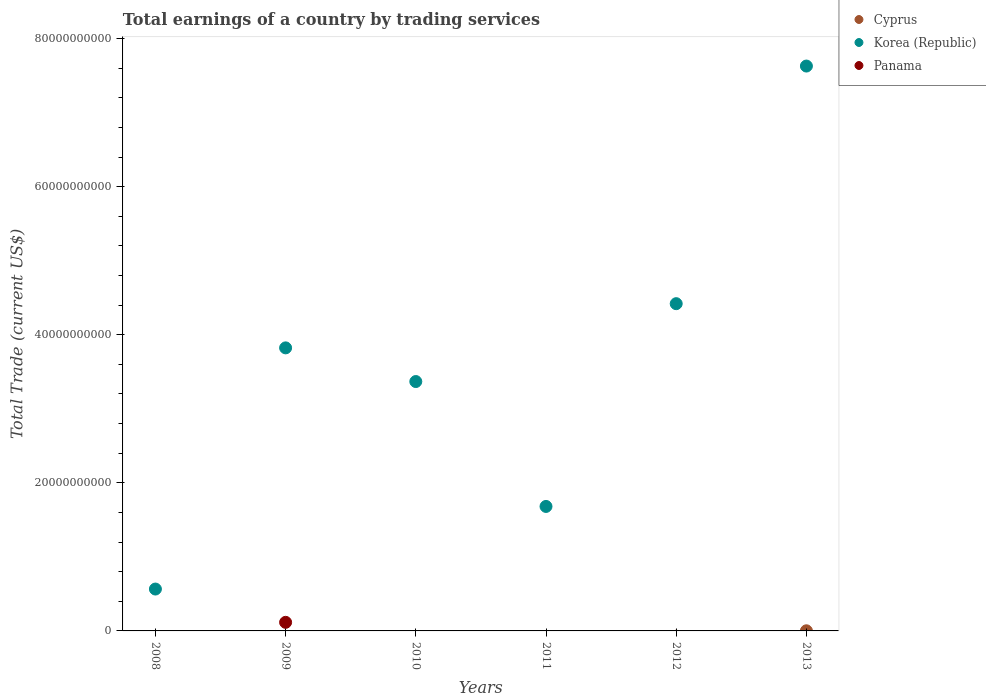What is the total earnings in Panama in 2011?
Provide a succinct answer. 0. Across all years, what is the maximum total earnings in Korea (Republic)?
Your response must be concise. 7.63e+1. Across all years, what is the minimum total earnings in Korea (Republic)?
Give a very brief answer. 5.65e+09. In which year was the total earnings in Cyprus maximum?
Your answer should be compact. 2013. What is the total total earnings in Panama in the graph?
Ensure brevity in your answer.  1.16e+09. What is the difference between the total earnings in Korea (Republic) in 2011 and that in 2013?
Your answer should be compact. -5.95e+1. What is the difference between the total earnings in Korea (Republic) in 2012 and the total earnings in Panama in 2008?
Give a very brief answer. 4.42e+1. What is the average total earnings in Korea (Republic) per year?
Keep it short and to the point. 3.58e+1. In the year 2009, what is the difference between the total earnings in Panama and total earnings in Korea (Republic)?
Ensure brevity in your answer.  -3.71e+1. In how many years, is the total earnings in Cyprus greater than 52000000000 US$?
Offer a terse response. 0. What is the ratio of the total earnings in Korea (Republic) in 2009 to that in 2013?
Your response must be concise. 0.5. Is the total earnings in Korea (Republic) in 2008 less than that in 2009?
Offer a terse response. Yes. What is the difference between the highest and the second highest total earnings in Korea (Republic)?
Keep it short and to the point. 3.21e+1. What is the difference between the highest and the lowest total earnings in Cyprus?
Give a very brief answer. 1.86e+07. In how many years, is the total earnings in Cyprus greater than the average total earnings in Cyprus taken over all years?
Your answer should be very brief. 1. Does the total earnings in Cyprus monotonically increase over the years?
Provide a succinct answer. No. How many dotlines are there?
Give a very brief answer. 3. Does the graph contain grids?
Your answer should be compact. No. Where does the legend appear in the graph?
Your answer should be compact. Top right. How many legend labels are there?
Your response must be concise. 3. How are the legend labels stacked?
Ensure brevity in your answer.  Vertical. What is the title of the graph?
Your response must be concise. Total earnings of a country by trading services. What is the label or title of the Y-axis?
Offer a terse response. Total Trade (current US$). What is the Total Trade (current US$) of Cyprus in 2008?
Your response must be concise. 0. What is the Total Trade (current US$) in Korea (Republic) in 2008?
Your response must be concise. 5.65e+09. What is the Total Trade (current US$) of Panama in 2008?
Offer a very short reply. 0. What is the Total Trade (current US$) of Cyprus in 2009?
Offer a terse response. 0. What is the Total Trade (current US$) in Korea (Republic) in 2009?
Give a very brief answer. 3.82e+1. What is the Total Trade (current US$) in Panama in 2009?
Give a very brief answer. 1.16e+09. What is the Total Trade (current US$) in Cyprus in 2010?
Offer a terse response. 0. What is the Total Trade (current US$) of Korea (Republic) in 2010?
Keep it short and to the point. 3.37e+1. What is the Total Trade (current US$) in Panama in 2010?
Offer a terse response. 0. What is the Total Trade (current US$) in Korea (Republic) in 2011?
Provide a succinct answer. 1.68e+1. What is the Total Trade (current US$) in Korea (Republic) in 2012?
Keep it short and to the point. 4.42e+1. What is the Total Trade (current US$) in Panama in 2012?
Keep it short and to the point. 0. What is the Total Trade (current US$) of Cyprus in 2013?
Offer a terse response. 1.86e+07. What is the Total Trade (current US$) in Korea (Republic) in 2013?
Your answer should be very brief. 7.63e+1. What is the Total Trade (current US$) in Panama in 2013?
Provide a short and direct response. 0. Across all years, what is the maximum Total Trade (current US$) of Cyprus?
Offer a very short reply. 1.86e+07. Across all years, what is the maximum Total Trade (current US$) in Korea (Republic)?
Keep it short and to the point. 7.63e+1. Across all years, what is the maximum Total Trade (current US$) of Panama?
Ensure brevity in your answer.  1.16e+09. Across all years, what is the minimum Total Trade (current US$) in Korea (Republic)?
Keep it short and to the point. 5.65e+09. Across all years, what is the minimum Total Trade (current US$) of Panama?
Ensure brevity in your answer.  0. What is the total Total Trade (current US$) in Cyprus in the graph?
Provide a short and direct response. 1.86e+07. What is the total Total Trade (current US$) in Korea (Republic) in the graph?
Your response must be concise. 2.15e+11. What is the total Total Trade (current US$) of Panama in the graph?
Your answer should be compact. 1.16e+09. What is the difference between the Total Trade (current US$) of Korea (Republic) in 2008 and that in 2009?
Your answer should be compact. -3.26e+1. What is the difference between the Total Trade (current US$) in Korea (Republic) in 2008 and that in 2010?
Ensure brevity in your answer.  -2.80e+1. What is the difference between the Total Trade (current US$) of Korea (Republic) in 2008 and that in 2011?
Make the answer very short. -1.12e+1. What is the difference between the Total Trade (current US$) in Korea (Republic) in 2008 and that in 2012?
Your answer should be very brief. -3.85e+1. What is the difference between the Total Trade (current US$) of Korea (Republic) in 2008 and that in 2013?
Keep it short and to the point. -7.06e+1. What is the difference between the Total Trade (current US$) in Korea (Republic) in 2009 and that in 2010?
Provide a succinct answer. 4.55e+09. What is the difference between the Total Trade (current US$) in Korea (Republic) in 2009 and that in 2011?
Provide a succinct answer. 2.14e+1. What is the difference between the Total Trade (current US$) of Korea (Republic) in 2009 and that in 2012?
Make the answer very short. -5.97e+09. What is the difference between the Total Trade (current US$) of Korea (Republic) in 2009 and that in 2013?
Your answer should be compact. -3.81e+1. What is the difference between the Total Trade (current US$) in Korea (Republic) in 2010 and that in 2011?
Your answer should be compact. 1.69e+1. What is the difference between the Total Trade (current US$) of Korea (Republic) in 2010 and that in 2012?
Give a very brief answer. -1.05e+1. What is the difference between the Total Trade (current US$) of Korea (Republic) in 2010 and that in 2013?
Make the answer very short. -4.26e+1. What is the difference between the Total Trade (current US$) in Korea (Republic) in 2011 and that in 2012?
Ensure brevity in your answer.  -2.74e+1. What is the difference between the Total Trade (current US$) of Korea (Republic) in 2011 and that in 2013?
Provide a short and direct response. -5.95e+1. What is the difference between the Total Trade (current US$) in Korea (Republic) in 2012 and that in 2013?
Your response must be concise. -3.21e+1. What is the difference between the Total Trade (current US$) of Korea (Republic) in 2008 and the Total Trade (current US$) of Panama in 2009?
Your answer should be compact. 4.50e+09. What is the average Total Trade (current US$) in Cyprus per year?
Offer a very short reply. 3.11e+06. What is the average Total Trade (current US$) in Korea (Republic) per year?
Offer a very short reply. 3.58e+1. What is the average Total Trade (current US$) of Panama per year?
Your answer should be compact. 1.93e+08. In the year 2009, what is the difference between the Total Trade (current US$) of Korea (Republic) and Total Trade (current US$) of Panama?
Provide a succinct answer. 3.71e+1. In the year 2013, what is the difference between the Total Trade (current US$) in Cyprus and Total Trade (current US$) in Korea (Republic)?
Ensure brevity in your answer.  -7.63e+1. What is the ratio of the Total Trade (current US$) in Korea (Republic) in 2008 to that in 2009?
Make the answer very short. 0.15. What is the ratio of the Total Trade (current US$) of Korea (Republic) in 2008 to that in 2010?
Your answer should be very brief. 0.17. What is the ratio of the Total Trade (current US$) of Korea (Republic) in 2008 to that in 2011?
Provide a short and direct response. 0.34. What is the ratio of the Total Trade (current US$) in Korea (Republic) in 2008 to that in 2012?
Provide a short and direct response. 0.13. What is the ratio of the Total Trade (current US$) of Korea (Republic) in 2008 to that in 2013?
Provide a succinct answer. 0.07. What is the ratio of the Total Trade (current US$) in Korea (Republic) in 2009 to that in 2010?
Your answer should be compact. 1.14. What is the ratio of the Total Trade (current US$) of Korea (Republic) in 2009 to that in 2011?
Offer a very short reply. 2.27. What is the ratio of the Total Trade (current US$) of Korea (Republic) in 2009 to that in 2012?
Give a very brief answer. 0.86. What is the ratio of the Total Trade (current US$) in Korea (Republic) in 2009 to that in 2013?
Ensure brevity in your answer.  0.5. What is the ratio of the Total Trade (current US$) of Korea (Republic) in 2010 to that in 2011?
Provide a short and direct response. 2. What is the ratio of the Total Trade (current US$) of Korea (Republic) in 2010 to that in 2012?
Your answer should be very brief. 0.76. What is the ratio of the Total Trade (current US$) in Korea (Republic) in 2010 to that in 2013?
Keep it short and to the point. 0.44. What is the ratio of the Total Trade (current US$) of Korea (Republic) in 2011 to that in 2012?
Provide a succinct answer. 0.38. What is the ratio of the Total Trade (current US$) of Korea (Republic) in 2011 to that in 2013?
Keep it short and to the point. 0.22. What is the ratio of the Total Trade (current US$) in Korea (Republic) in 2012 to that in 2013?
Keep it short and to the point. 0.58. What is the difference between the highest and the second highest Total Trade (current US$) of Korea (Republic)?
Keep it short and to the point. 3.21e+1. What is the difference between the highest and the lowest Total Trade (current US$) of Cyprus?
Provide a short and direct response. 1.86e+07. What is the difference between the highest and the lowest Total Trade (current US$) of Korea (Republic)?
Your response must be concise. 7.06e+1. What is the difference between the highest and the lowest Total Trade (current US$) in Panama?
Provide a short and direct response. 1.16e+09. 